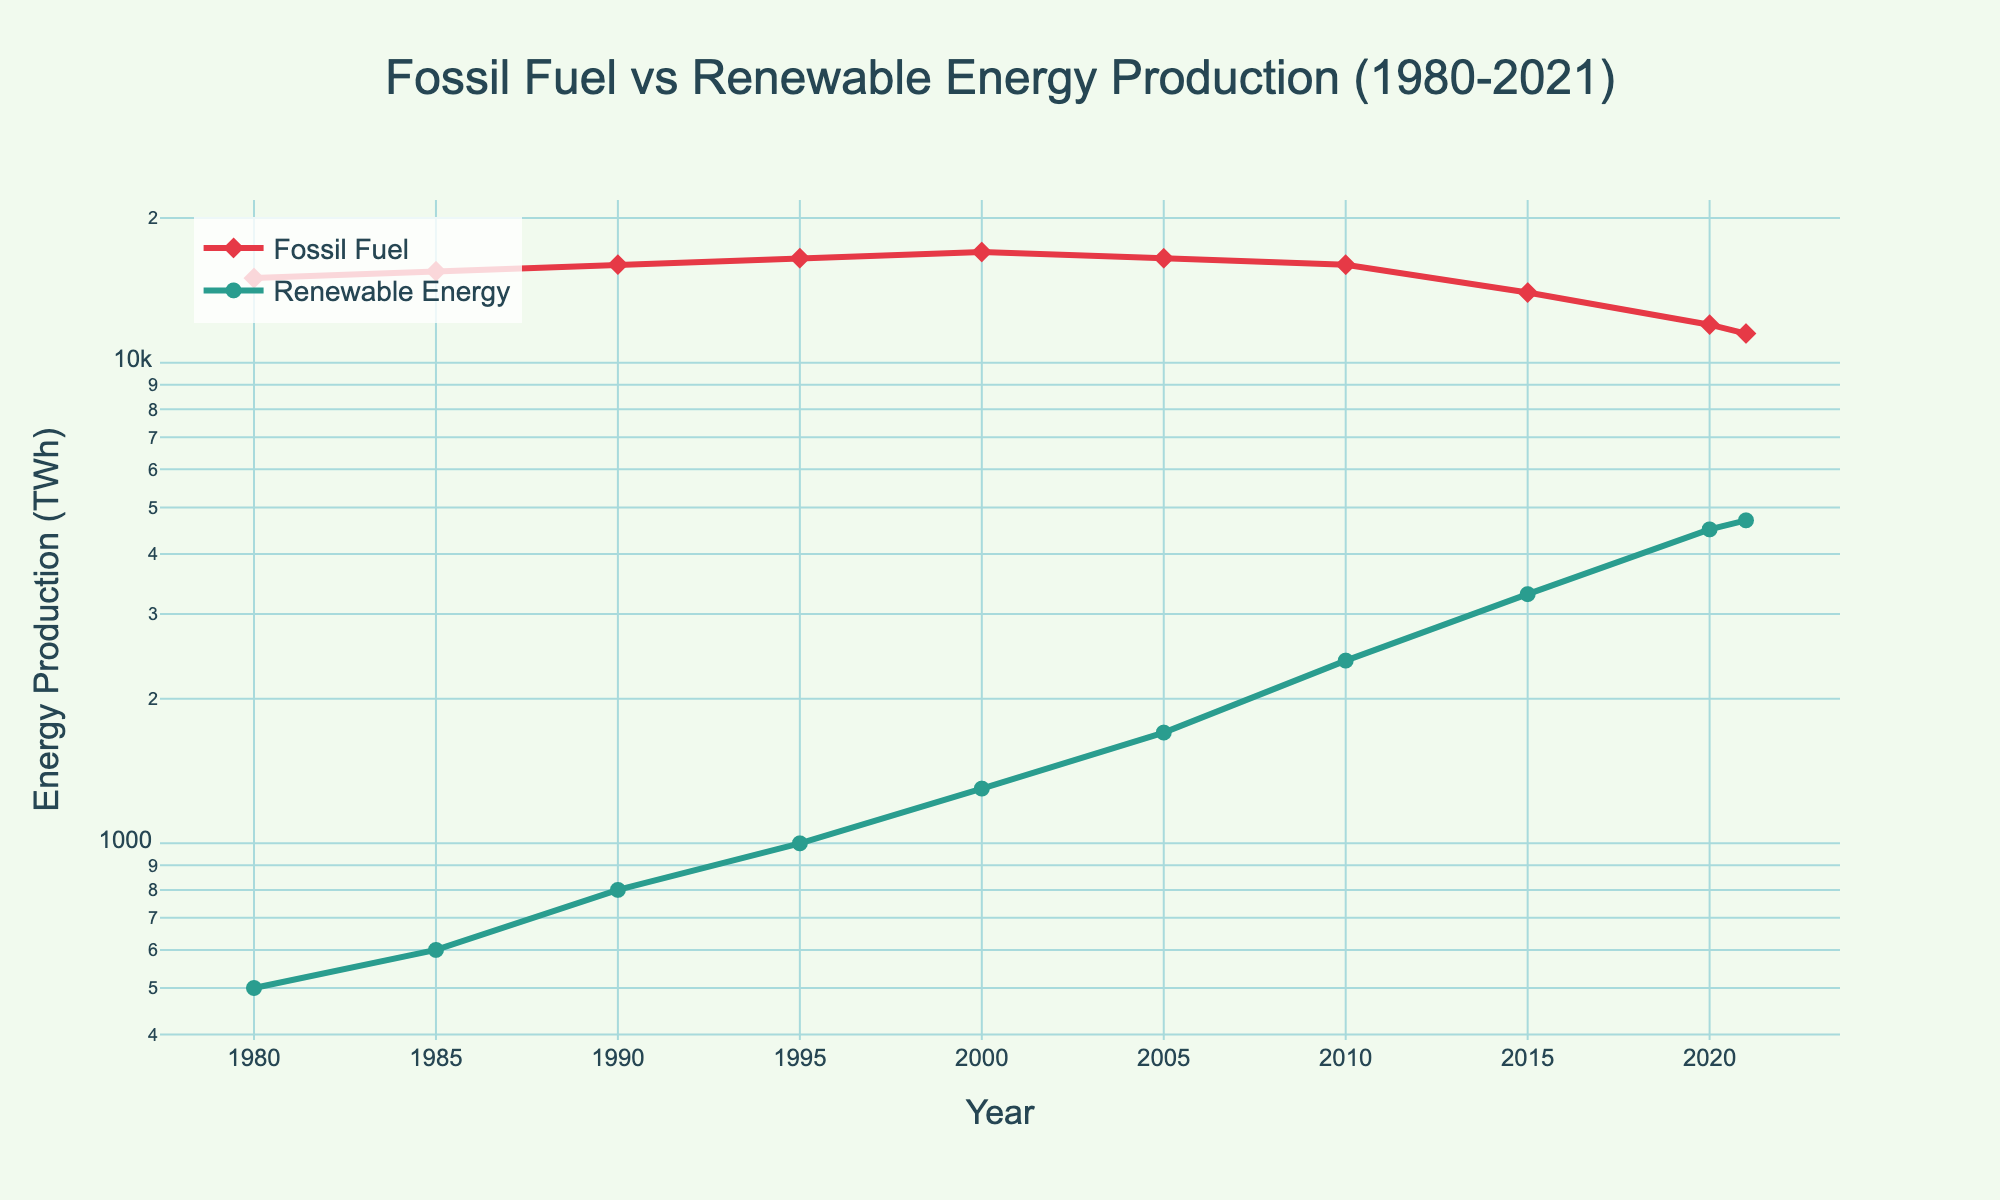What is the title of the plot? The title is usually located at the top of the plot and provides a brief description of what the figure represents. Here, it is prominently displayed at the center.
Answer: Fossil Fuel vs Renewable Energy Production (1980-2021) What is the color of the line representing Fossil Fuel Energy Production? By observing the color coding of the lines, we can identify the color assigned to the fossil fuel energy production trace.
Answer: Red What trend can be observed in Fossil Fuel Energy Production from 1980 to 2021? We can identify trends by observing the increase, decrease, or stabilization of the line over the respective period. Here, the fossil fuel energy production line declines from 2000 onwards.
Answer: Decreasing In which year did Renewable Energy Production first surpass 1000 TWh? By pinpointing the year along the x-axis and tracing its corresponding value on the renewable energy production line, we can find the exact year.
Answer: 1995 What was the Renewable Energy Production in the year 2010? We look at the renewable energy production line and find the value corresponding to the year 2010.
Answer: 2400 TWh What is the difference in Fossil Fuel Energy Production between 2000 and 2021? First, find the values for the years 2000 and 2021. Then subtract the value in 2021 from the value in 2000: 17000 TWh (2000) - 11500 TWh (2021).
Answer: 5500 TWh How many data points are plotted on the line representing Renewable Energy Production? By counting the markers on the renewable energy production line, we can determine the number of data points presented from 1980 to 2021.
Answer: 10 Which year shows the maximum Renewable Energy Production and what is that value? Locate the peak point on the renewable energy production line and read off the year and the corresponding value.
Answer: 2021, 4700 TWh How does the slope of the Fossil Fuel Energy Production line change around the year 2000? By observing the slope of the line around 2000, we notice a before-and-after trend. Prior to 2000, fossil fuel production increased, but post-2000, the slope turns negative, indicating a decrease.
Answer: It changes from positive to negative Which type of energy shows a more significant exponential growth trend in this period? By observing the curvature (steepness) of the lines on a log scale where exponential trends are linearized, the renewable energy production curve shows more pronounced growth trends compared to the relatively flatter fossil fuel curve.
Answer: Renewable Energy Production 